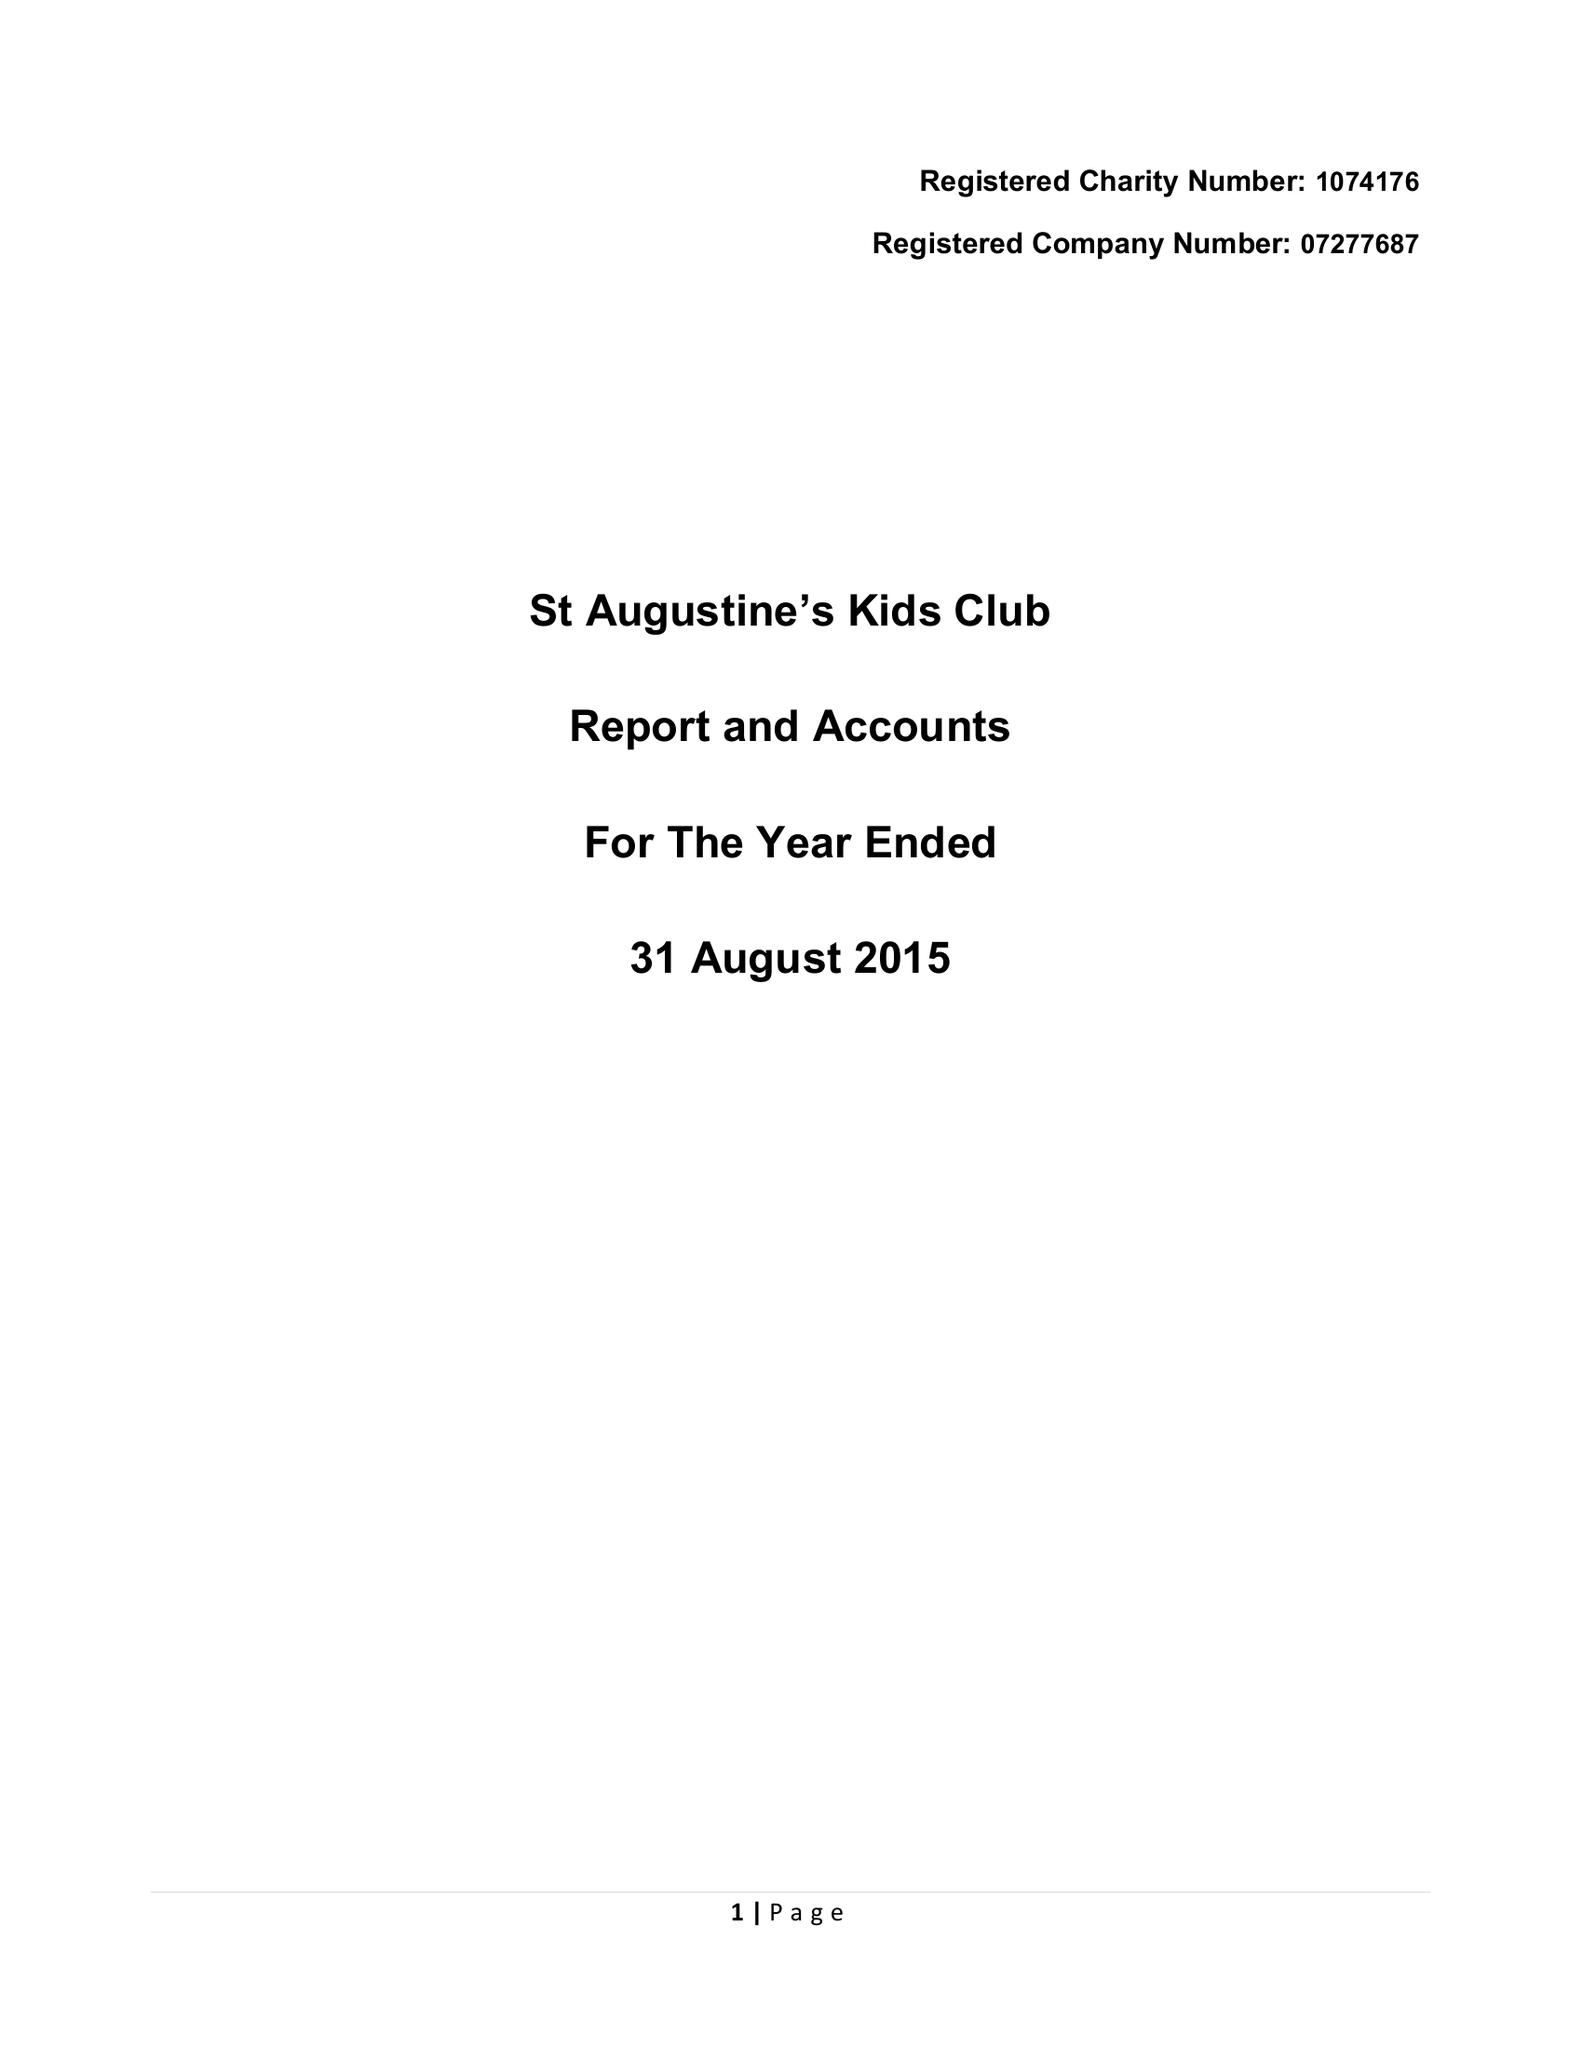What is the value for the address__post_town?
Answer the question using a single word or phrase. KENILWORTH 